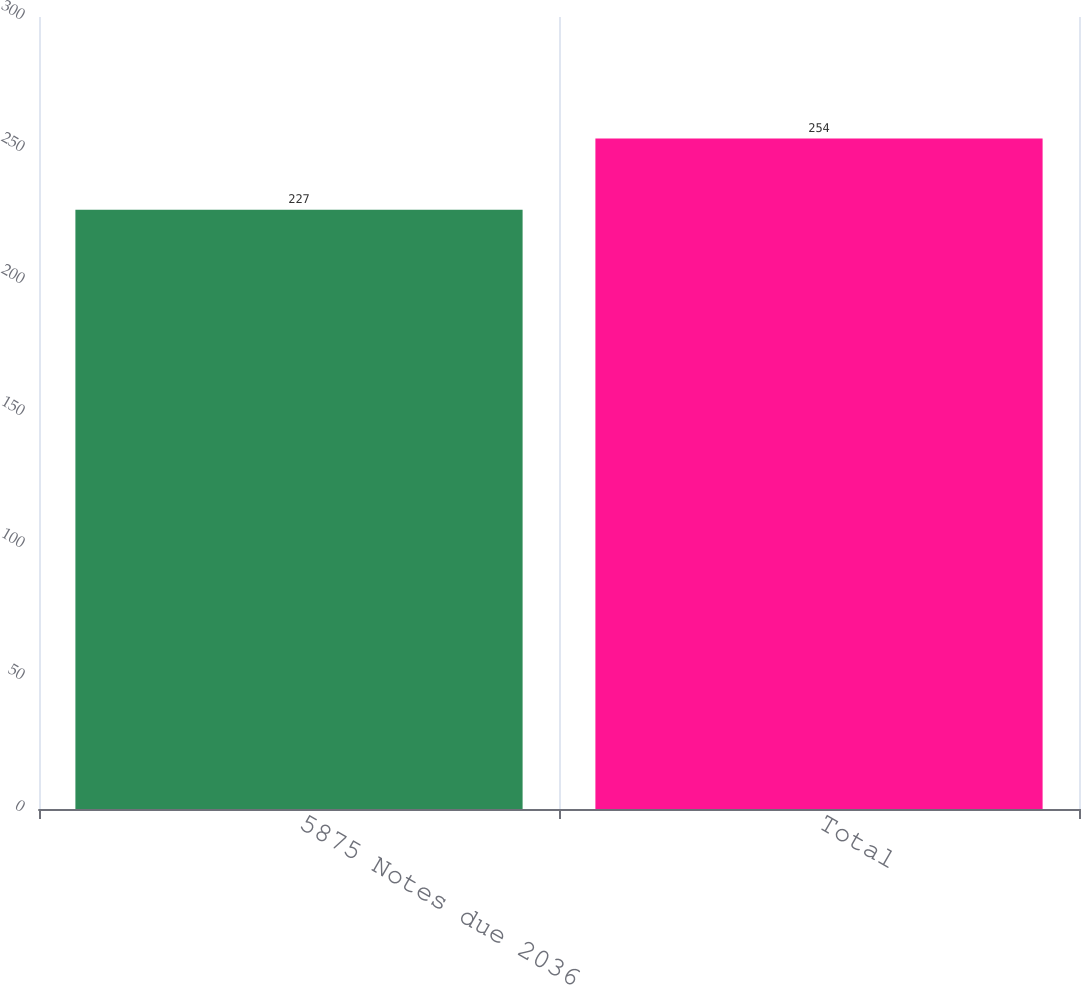Convert chart to OTSL. <chart><loc_0><loc_0><loc_500><loc_500><bar_chart><fcel>5875 Notes due 2036<fcel>Total<nl><fcel>227<fcel>254<nl></chart> 